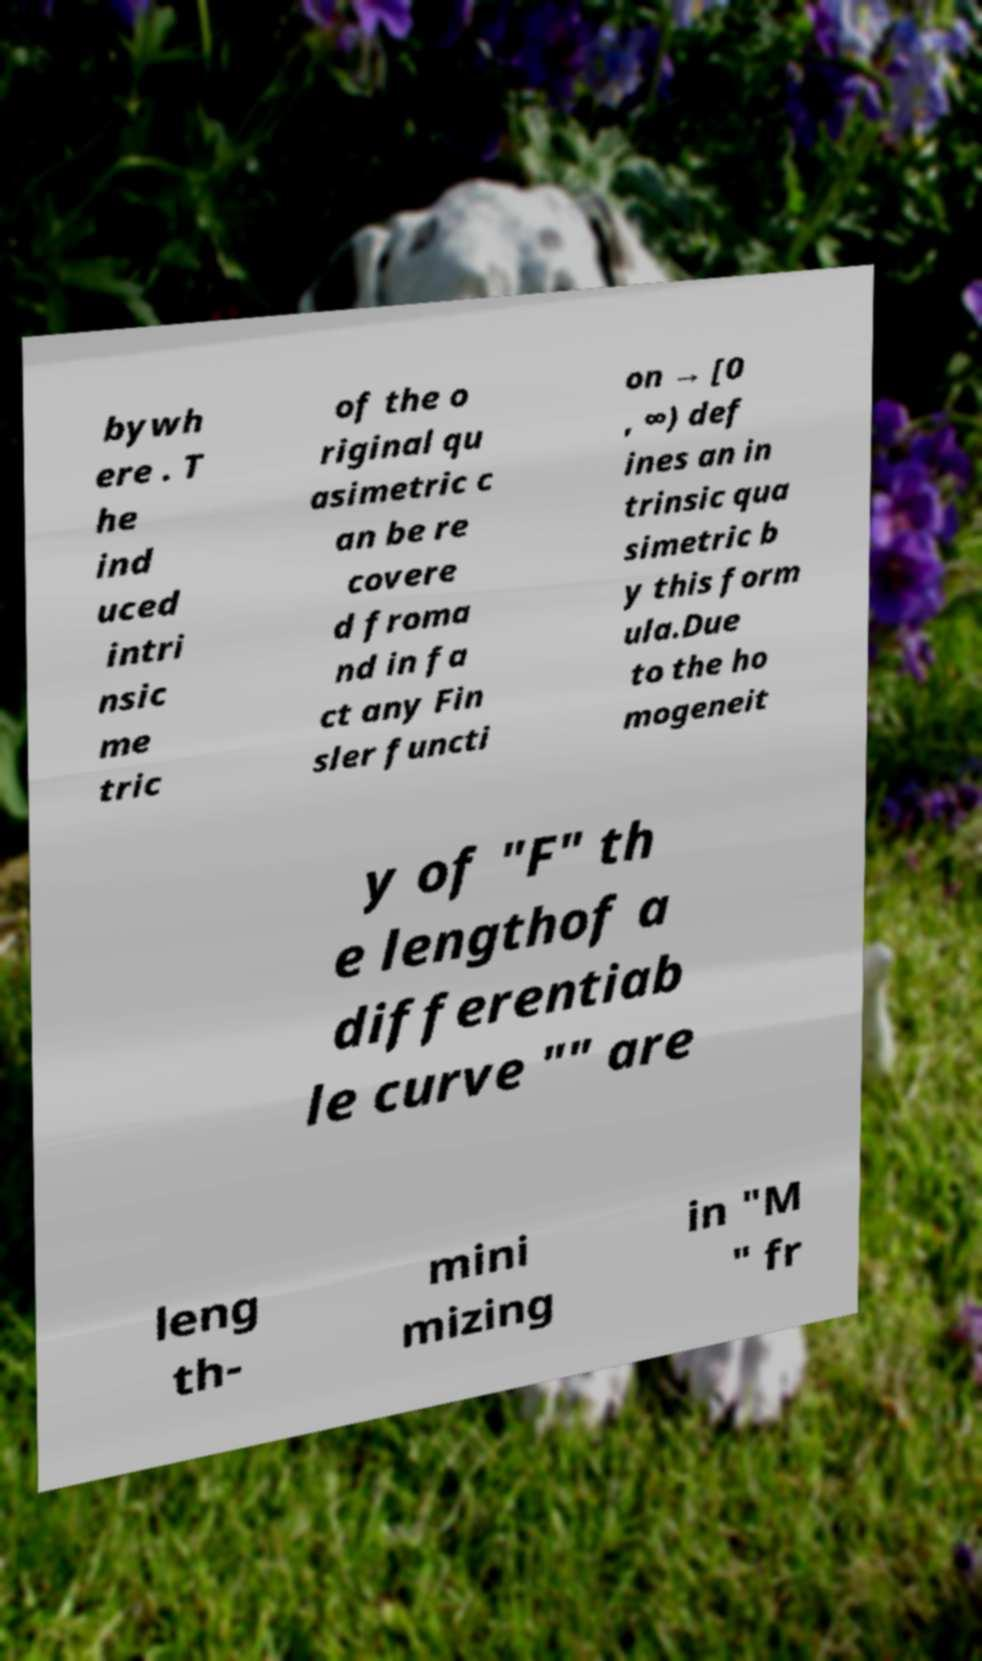Could you assist in decoding the text presented in this image and type it out clearly? bywh ere . T he ind uced intri nsic me tric of the o riginal qu asimetric c an be re covere d froma nd in fa ct any Fin sler functi on → [0 , ∞) def ines an in trinsic qua simetric b y this form ula.Due to the ho mogeneit y of "F" th e lengthof a differentiab le curve "" are leng th- mini mizing in "M " fr 